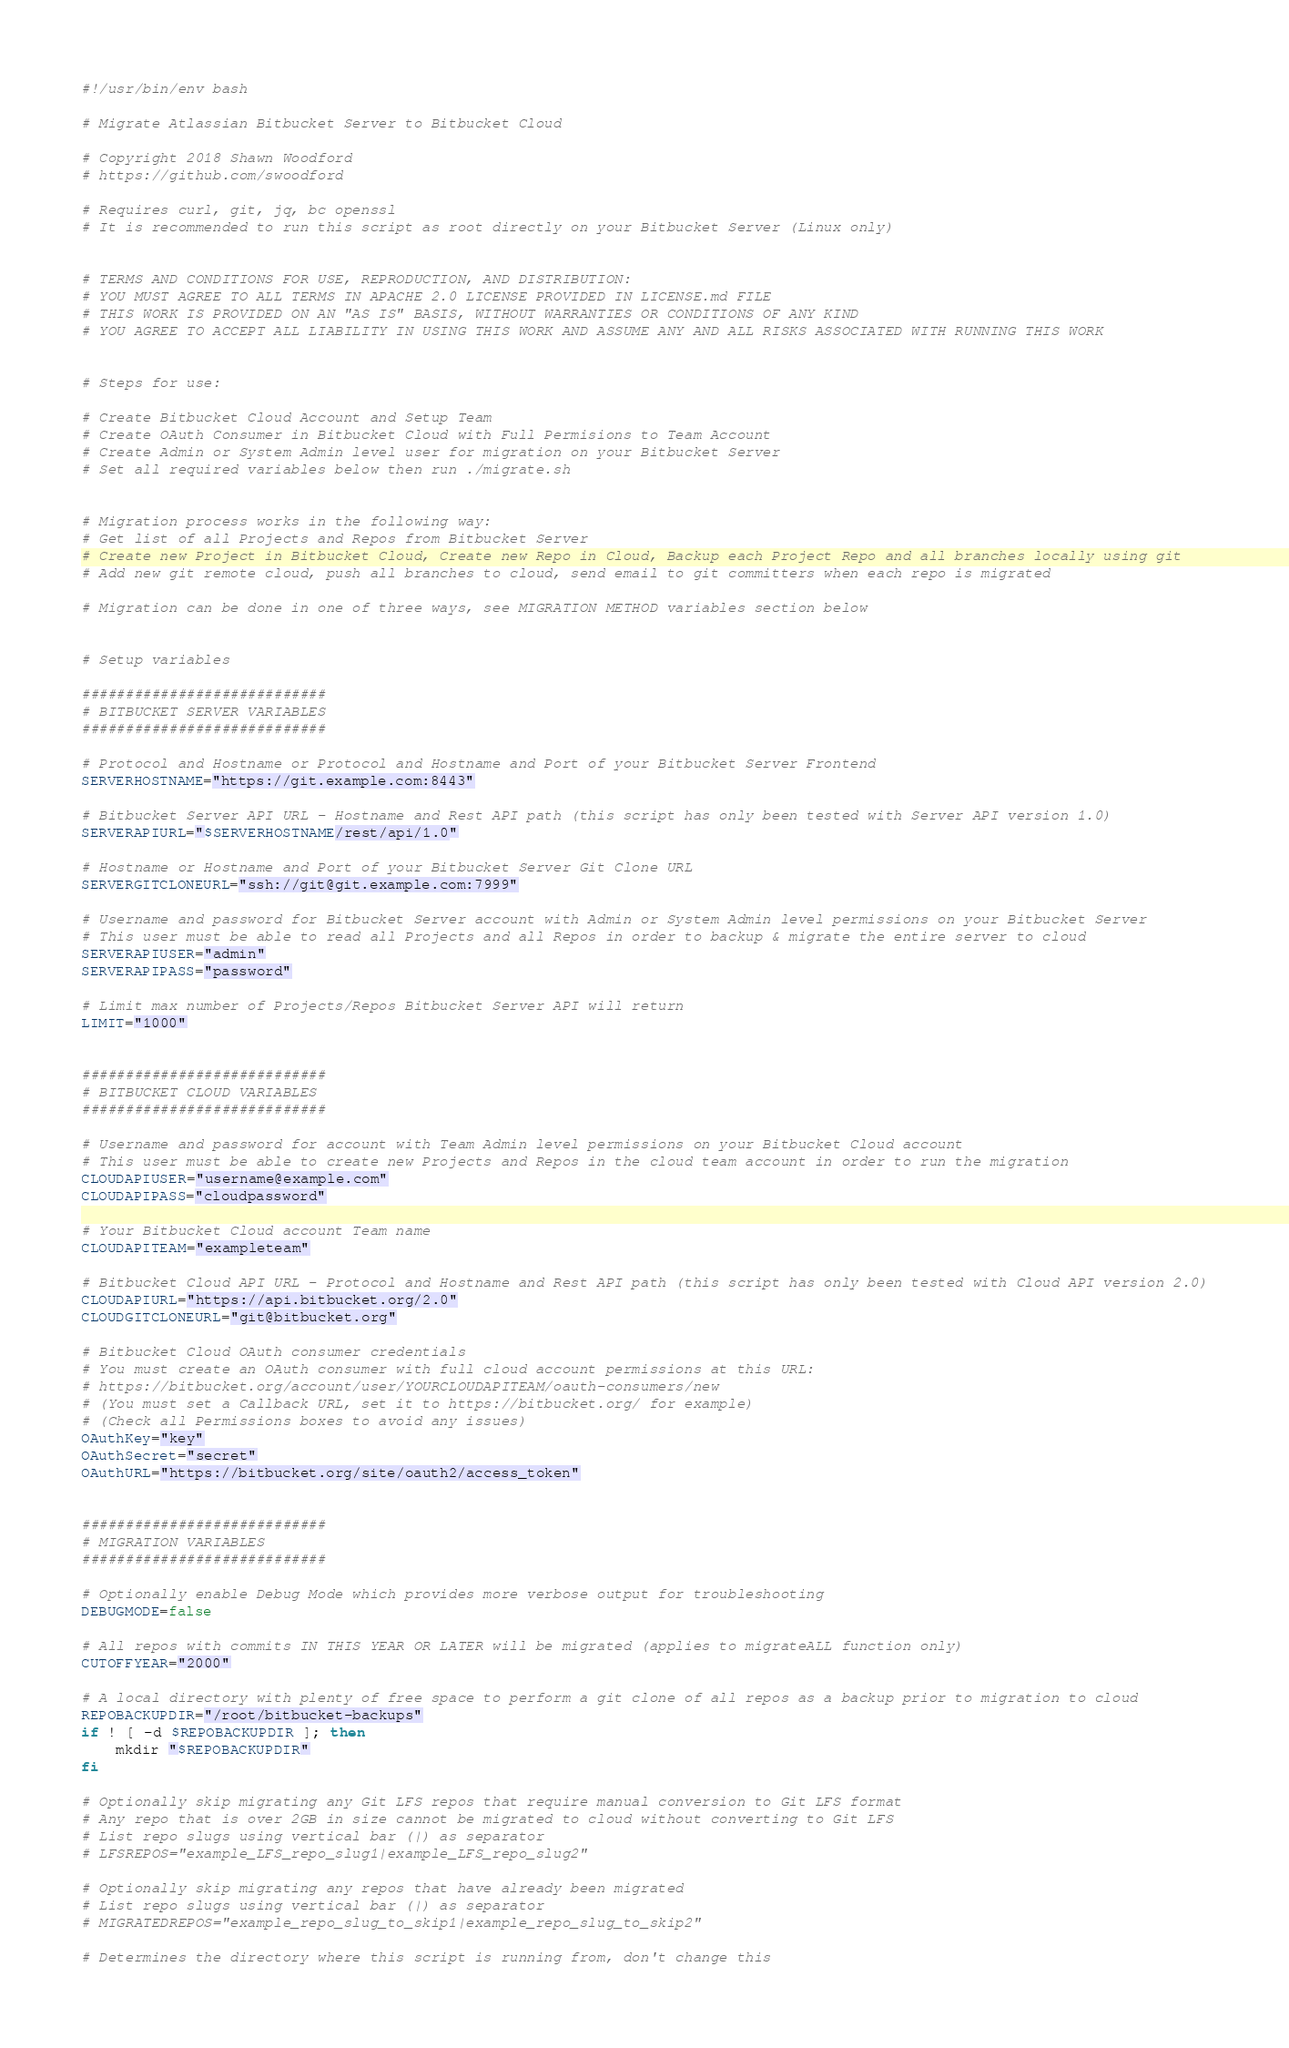Convert code to text. <code><loc_0><loc_0><loc_500><loc_500><_Bash_>#!/usr/bin/env bash

# Migrate Atlassian Bitbucket Server to Bitbucket Cloud

# Copyright 2018 Shawn Woodford
# https://github.com/swoodford

# Requires curl, git, jq, bc openssl
# It is recommended to run this script as root directly on your Bitbucket Server (Linux only)


# TERMS AND CONDITIONS FOR USE, REPRODUCTION, AND DISTRIBUTION:
# YOU MUST AGREE TO ALL TERMS IN APACHE 2.0 LICENSE PROVIDED IN LICENSE.md FILE
# THIS WORK IS PROVIDED ON AN "AS IS" BASIS, WITHOUT WARRANTIES OR CONDITIONS OF ANY KIND
# YOU AGREE TO ACCEPT ALL LIABILITY IN USING THIS WORK AND ASSUME ANY AND ALL RISKS ASSOCIATED WITH RUNNING THIS WORK


# Steps for use:

# Create Bitbucket Cloud Account and Setup Team
# Create OAuth Consumer in Bitbucket Cloud with Full Permisions to Team Account
# Create Admin or System Admin level user for migration on your Bitbucket Server
# Set all required variables below then run ./migrate.sh


# Migration process works in the following way:
# Get list of all Projects and Repos from Bitbucket Server
# Create new Project in Bitbucket Cloud, Create new Repo in Cloud, Backup each Project Repo and all branches locally using git
# Add new git remote cloud, push all branches to cloud, send email to git committers when each repo is migrated

# Migration can be done in one of three ways, see MIGRATION METHOD variables section below


# Setup variables

############################
# BITBUCKET SERVER VARIABLES
############################

# Protocol and Hostname or Protocol and Hostname and Port of your Bitbucket Server Frontend
SERVERHOSTNAME="https://git.example.com:8443"

# Bitbucket Server API URL - Hostname and Rest API path (this script has only been tested with Server API version 1.0)
SERVERAPIURL="$SERVERHOSTNAME/rest/api/1.0"

# Hostname or Hostname and Port of your Bitbucket Server Git Clone URL
SERVERGITCLONEURL="ssh://git@git.example.com:7999"

# Username and password for Bitbucket Server account with Admin or System Admin level permissions on your Bitbucket Server
# This user must be able to read all Projects and all Repos in order to backup & migrate the entire server to cloud
SERVERAPIUSER="admin"
SERVERAPIPASS="password"

# Limit max number of Projects/Repos Bitbucket Server API will return
LIMIT="1000"


############################
# BITBUCKET CLOUD VARIABLES
############################

# Username and password for account with Team Admin level permissions on your Bitbucket Cloud account
# This user must be able to create new Projects and Repos in the cloud team account in order to run the migration
CLOUDAPIUSER="username@example.com"
CLOUDAPIPASS="cloudpassword"

# Your Bitbucket Cloud account Team name
CLOUDAPITEAM="exampleteam"

# Bitbucket Cloud API URL - Protocol and Hostname and Rest API path (this script has only been tested with Cloud API version 2.0)
CLOUDAPIURL="https://api.bitbucket.org/2.0"
CLOUDGITCLONEURL="git@bitbucket.org"

# Bitbucket Cloud OAuth consumer credentials
# You must create an OAuth consumer with full cloud account permissions at this URL:
# https://bitbucket.org/account/user/YOURCLOUDAPITEAM/oauth-consumers/new
# (You must set a Callback URL, set it to https://bitbucket.org/ for example)
# (Check all Permissions boxes to avoid any issues)
OAuthKey="key"
OAuthSecret="secret"
OAuthURL="https://bitbucket.org/site/oauth2/access_token"


############################
# MIGRATION VARIABLES
############################

# Optionally enable Debug Mode which provides more verbose output for troubleshooting
DEBUGMODE=false

# All repos with commits IN THIS YEAR OR LATER will be migrated (applies to migrateALL function only)
CUTOFFYEAR="2000"

# A local directory with plenty of free space to perform a git clone of all repos as a backup prior to migration to cloud
REPOBACKUPDIR="/root/bitbucket-backups"
if ! [ -d $REPOBACKUPDIR ]; then
	mkdir "$REPOBACKUPDIR"
fi

# Optionally skip migrating any Git LFS repos that require manual conversion to Git LFS format
# Any repo that is over 2GB in size cannot be migrated to cloud without converting to Git LFS
# List repo slugs using vertical bar (|) as separator
# LFSREPOS="example_LFS_repo_slug1|example_LFS_repo_slug2"

# Optionally skip migrating any repos that have already been migrated
# List repo slugs using vertical bar (|) as separator
# MIGRATEDREPOS="example_repo_slug_to_skip1|example_repo_slug_to_skip2"

# Determines the directory where this script is running from, don't change this</code> 